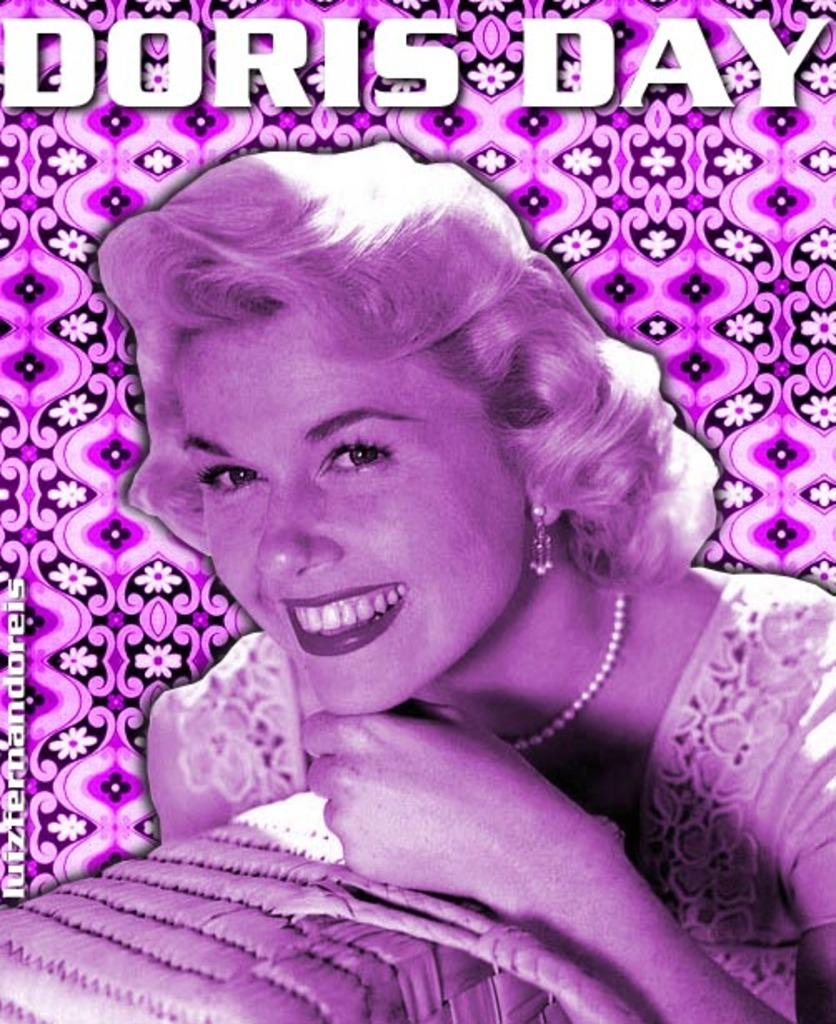What is the main subject of the image? There is a poster in the image. What can be seen on the poster? The poster contains an image of a woman smiling. Is there any text on the poster? Yes, there is text at the top of the image. How much debt is the woman in the poster trying to pay off? There is no mention of debt in the image, as it only features a woman smiling and text at the top. 